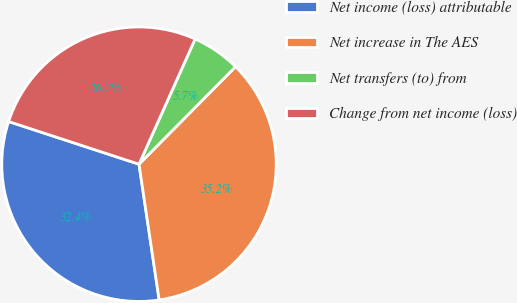Convert chart. <chart><loc_0><loc_0><loc_500><loc_500><pie_chart><fcel>Net income (loss) attributable<fcel>Net increase in The AES<fcel>Net transfers (to) from<fcel>Change from net income (loss)<nl><fcel>32.38%<fcel>35.23%<fcel>5.71%<fcel>26.67%<nl></chart> 